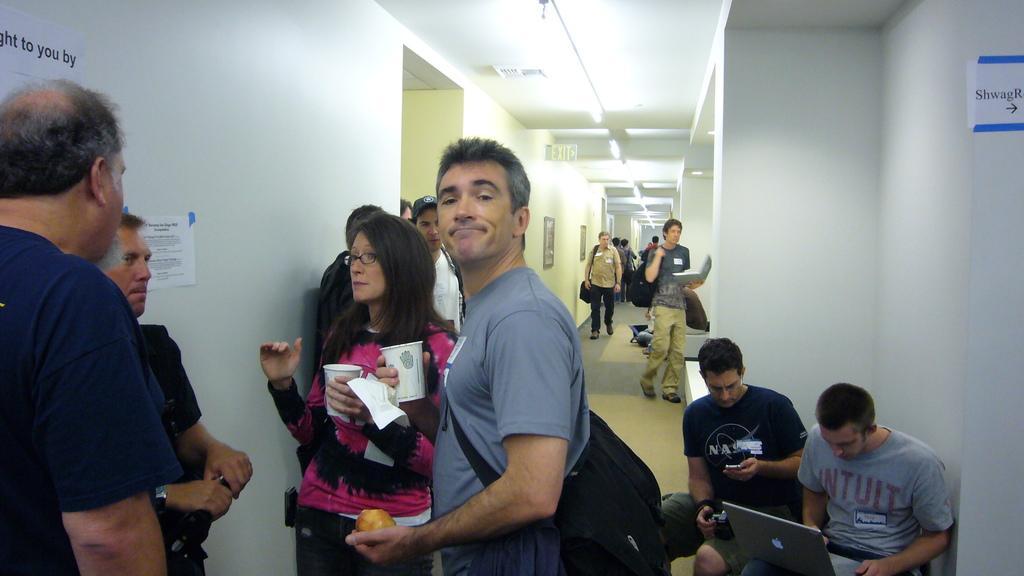Please provide a concise description of this image. At the top we can see ceiling, lights and an exit board. Here we can see paper notes and frames on the walls. We can see people standing, walking and sitting. This man is holding a glass, tissue paper and a fruit. He is smiling. 